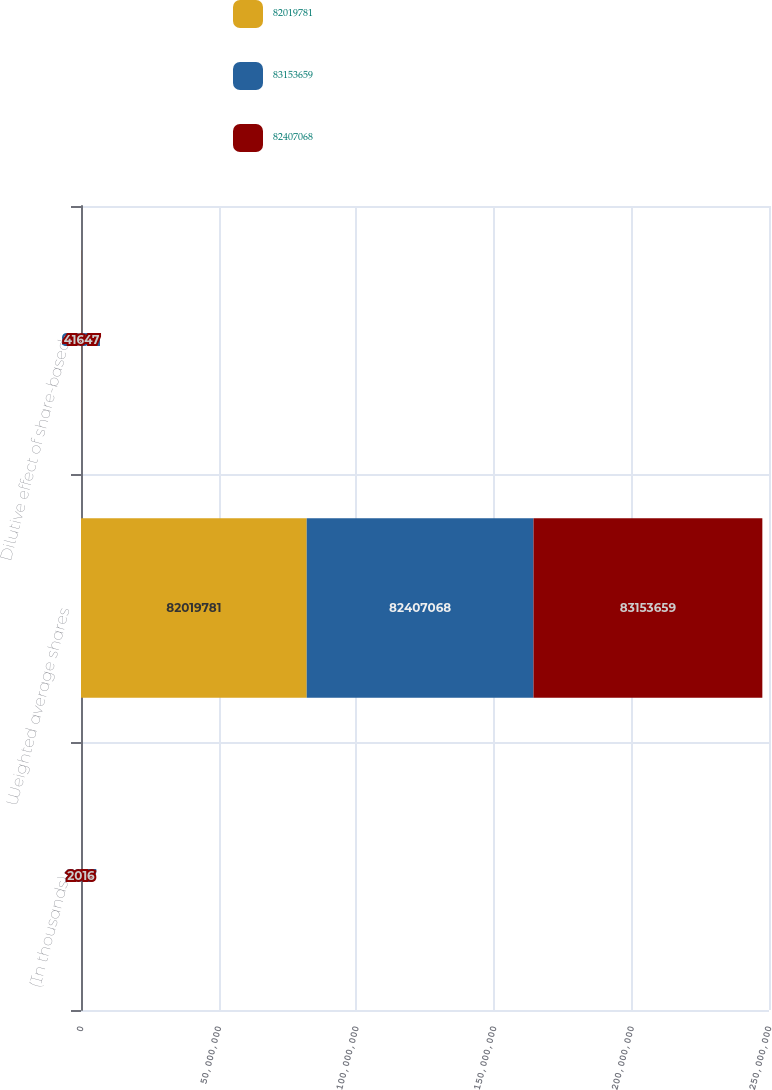Convert chart to OTSL. <chart><loc_0><loc_0><loc_500><loc_500><stacked_bar_chart><ecel><fcel>(In thousands)<fcel>Weighted average shares<fcel>Dilutive effect of share-based<nl><fcel>8.20198e+07<fcel>2018<fcel>8.20198e+07<fcel>96217<nl><fcel>8.31537e+07<fcel>2017<fcel>8.24071e+07<fcel>98651<nl><fcel>8.24071e+07<fcel>2016<fcel>8.31537e+07<fcel>41647<nl></chart> 